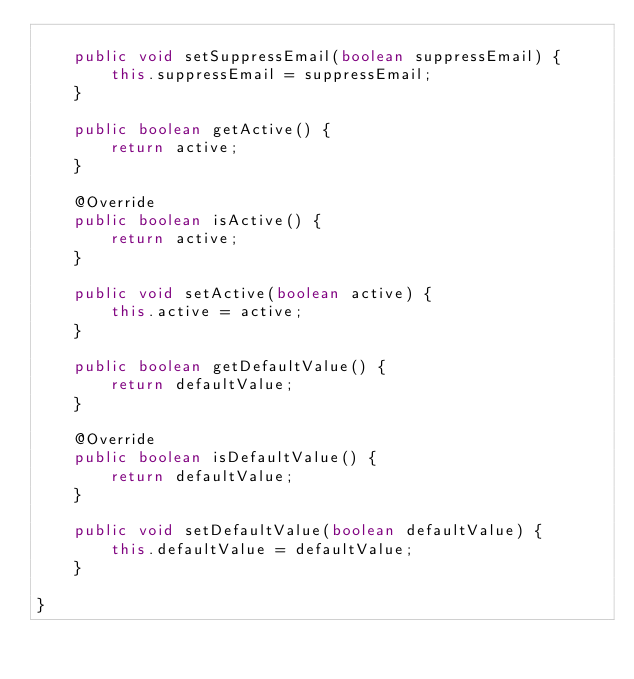Convert code to text. <code><loc_0><loc_0><loc_500><loc_500><_Java_>
    public void setSuppressEmail(boolean suppressEmail) {
        this.suppressEmail = suppressEmail;
    }

    public boolean getActive() {
        return active;
    }

    @Override
    public boolean isActive() {
        return active;
    }

    public void setActive(boolean active) {
        this.active = active;
    }

    public boolean getDefaultValue() {
        return defaultValue;
    }

    @Override
    public boolean isDefaultValue() {
        return defaultValue;
    }

    public void setDefaultValue(boolean defaultValue) {
        this.defaultValue = defaultValue;
    }

}
</code> 